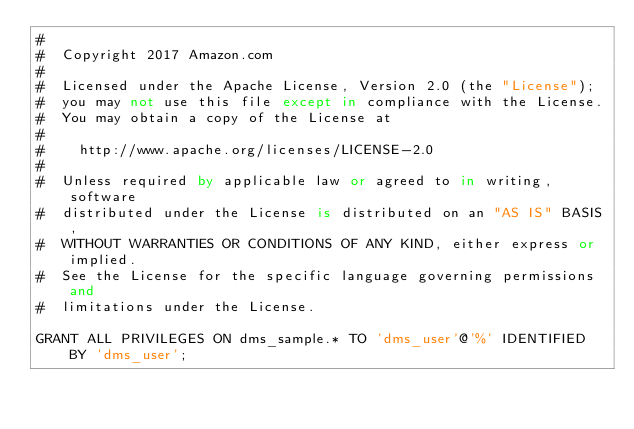<code> <loc_0><loc_0><loc_500><loc_500><_SQL_>#
#  Copyright 2017 Amazon.com
#
#  Licensed under the Apache License, Version 2.0 (the "License");
#  you may not use this file except in compliance with the License.
#  You may obtain a copy of the License at
#
#    http://www.apache.org/licenses/LICENSE-2.0
#
#  Unless required by applicable law or agreed to in writing, software
#  distributed under the License is distributed on an "AS IS" BASIS,
#  WITHOUT WARRANTIES OR CONDITIONS OF ANY KIND, either express or implied.
#  See the License for the specific language governing permissions and
#  limitations under the License.

GRANT ALL PRIVILEGES ON dms_sample.* TO 'dms_user'@'%' IDENTIFIED BY 'dms_user';
</code> 